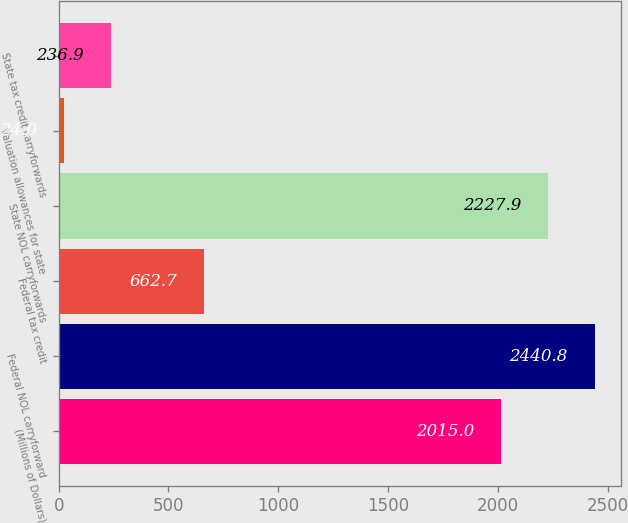<chart> <loc_0><loc_0><loc_500><loc_500><bar_chart><fcel>(Millions of Dollars)<fcel>Federal NOL carryforward<fcel>Federal tax credit<fcel>State NOL carryforwards<fcel>Valuation allowances for state<fcel>State tax credit carryforwards<nl><fcel>2015<fcel>2440.8<fcel>662.7<fcel>2227.9<fcel>24<fcel>236.9<nl></chart> 